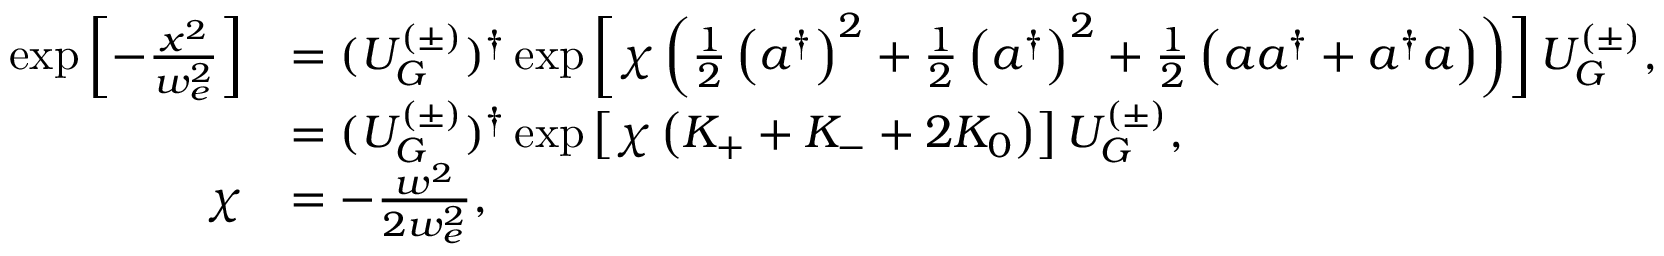<formula> <loc_0><loc_0><loc_500><loc_500>\begin{array} { r l } { \exp \left [ - \frac { x ^ { 2 } } { w _ { e } ^ { 2 } } \right ] } & { = ( U _ { G } ^ { ( \pm ) } ) ^ { \dag } \exp \left [ \chi \left ( \frac { 1 } { 2 } \left ( a ^ { \dag } \right ) ^ { 2 } + \frac { 1 } { 2 } \left ( a ^ { \dag } \right ) ^ { 2 } + \frac { 1 } { 2 } \left ( a a ^ { \dag } + a ^ { \dag } a \right ) \right ) \right ] U _ { G } ^ { ( \pm ) } , } \\ & { = ( U _ { G } ^ { ( \pm ) } ) ^ { \dag } \exp \left [ \chi \left ( K _ { + } + K _ { - } + 2 K _ { 0 } \right ) \right ] U _ { G } ^ { ( \pm ) } , } \\ { \chi } & { = - \frac { w ^ { 2 } } { 2 w _ { e } ^ { 2 } } , } \end{array}</formula> 